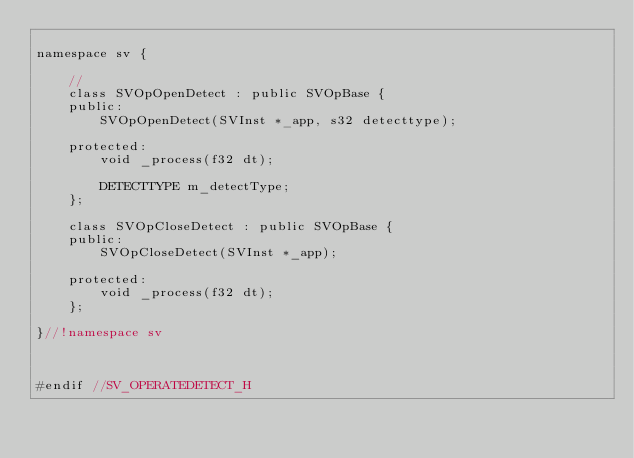Convert code to text. <code><loc_0><loc_0><loc_500><loc_500><_C_>
namespace sv {
    
    //
    class SVOpOpenDetect : public SVOpBase {
    public:
        SVOpOpenDetect(SVInst *_app, s32 detecttype);
        
    protected:
        void _process(f32 dt);
        
        DETECTTYPE m_detectType;
    };
    
    class SVOpCloseDetect : public SVOpBase {
    public:
        SVOpCloseDetect(SVInst *_app);
        
    protected:
        void _process(f32 dt);
    };
    
}//!namespace sv



#endif //SV_OPERATEDETECT_H
</code> 